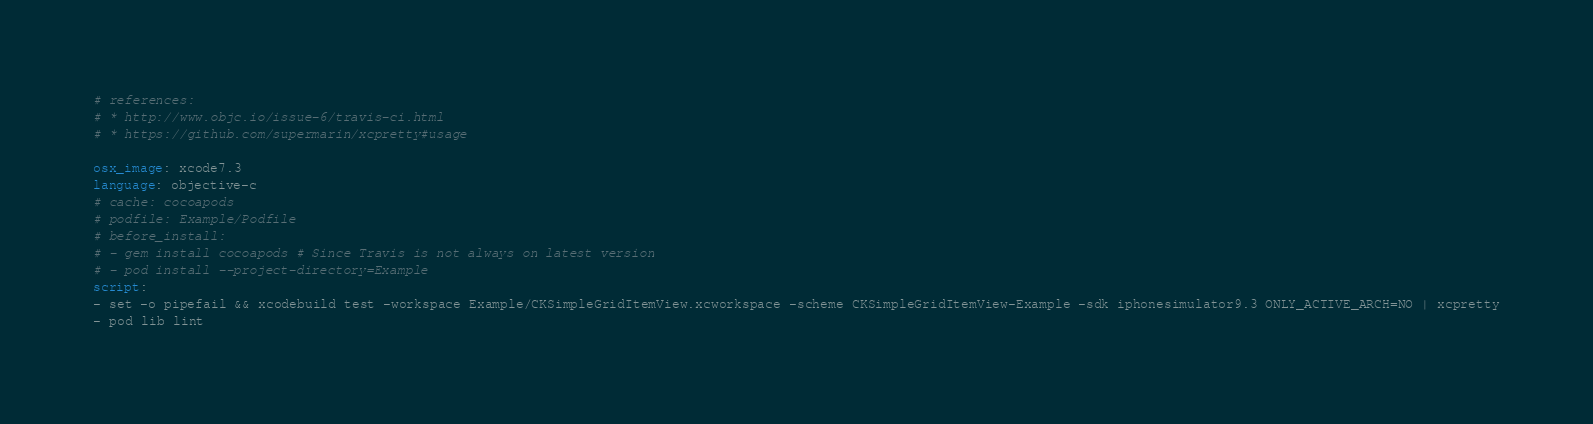Convert code to text. <code><loc_0><loc_0><loc_500><loc_500><_YAML_># references:
# * http://www.objc.io/issue-6/travis-ci.html
# * https://github.com/supermarin/xcpretty#usage

osx_image: xcode7.3
language: objective-c
# cache: cocoapods
# podfile: Example/Podfile
# before_install:
# - gem install cocoapods # Since Travis is not always on latest version
# - pod install --project-directory=Example
script:
- set -o pipefail && xcodebuild test -workspace Example/CKSimpleGridItemView.xcworkspace -scheme CKSimpleGridItemView-Example -sdk iphonesimulator9.3 ONLY_ACTIVE_ARCH=NO | xcpretty
- pod lib lint
</code> 